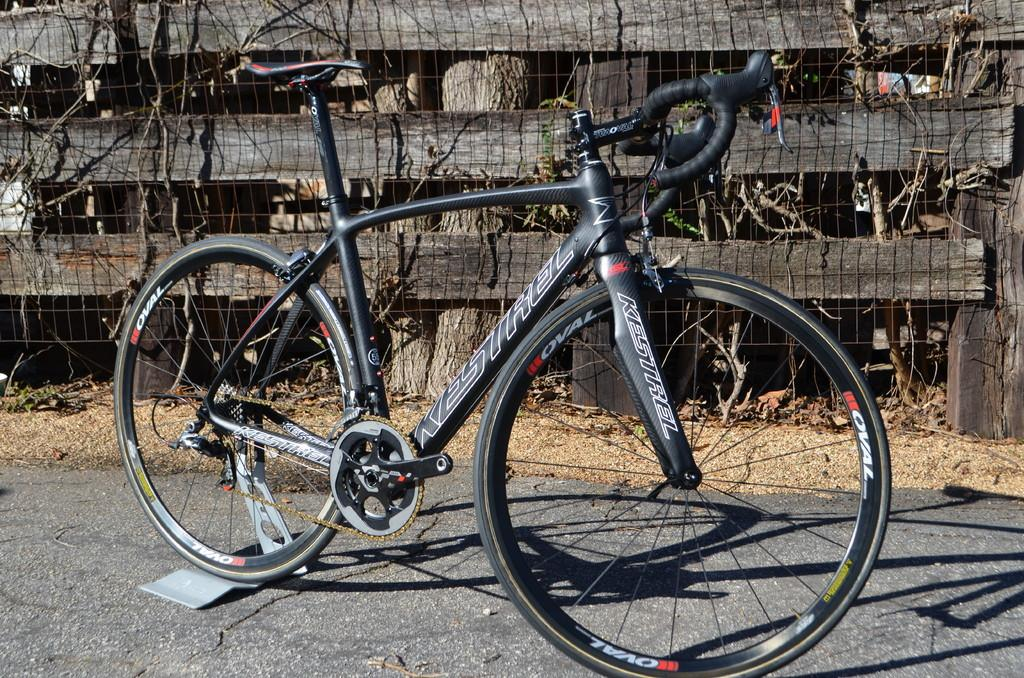What is the main object in the image? There is a bicycle in the image. Where is the bicycle located? The bicycle is on the road. What can be seen in the background of the image? There is a fencing and a plant in the background of the image. How many minutes does it take for the bomb to explode in the image? There is no bomb present in the image, so it is not possible to answer that question. 